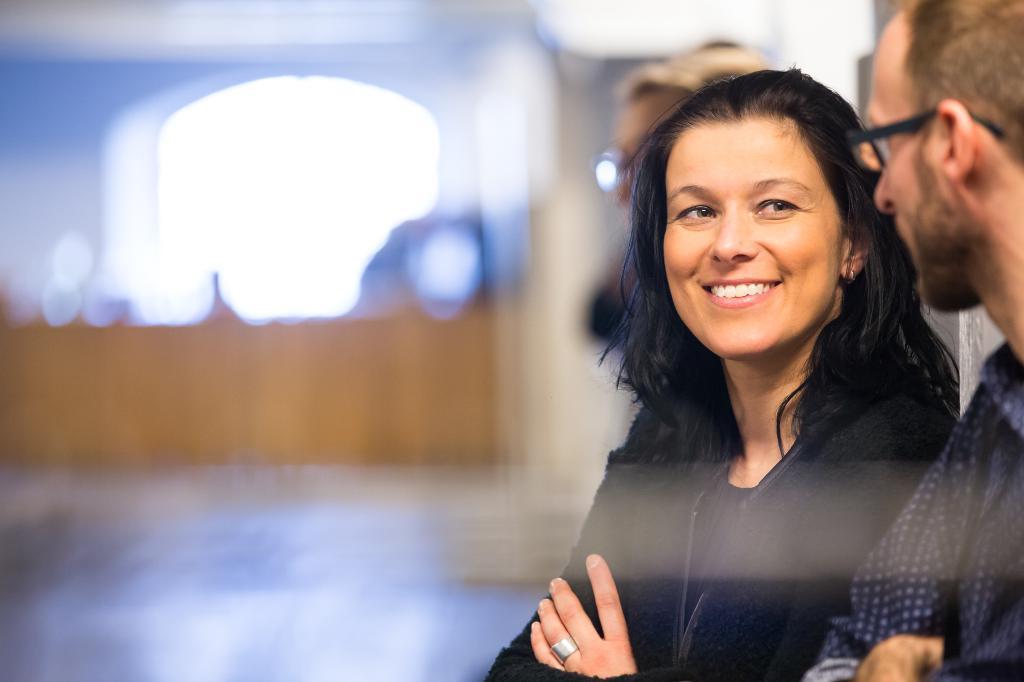In one or two sentences, can you explain what this image depicts? In this image I see a man and a woman and I see that this woman is smiling and I see another person over here and I see that it is totally blurred in the background. 